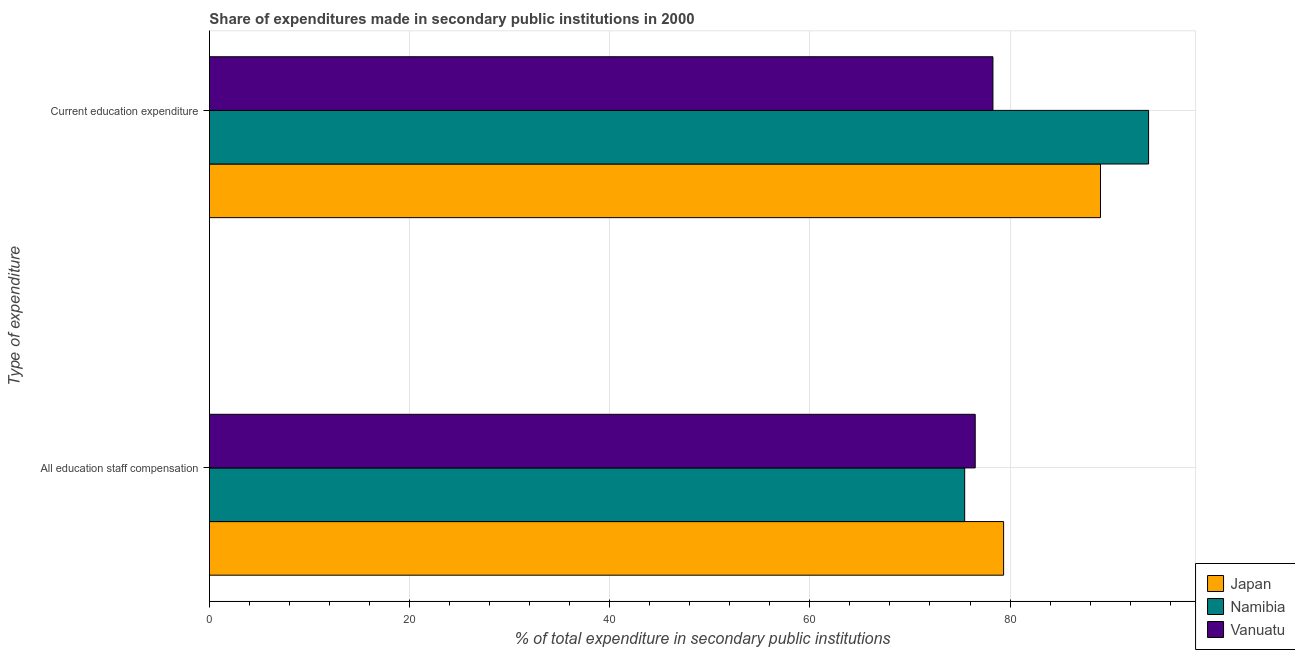How many different coloured bars are there?
Your answer should be very brief. 3. How many groups of bars are there?
Your answer should be very brief. 2. Are the number of bars on each tick of the Y-axis equal?
Offer a very short reply. Yes. How many bars are there on the 1st tick from the top?
Your answer should be compact. 3. How many bars are there on the 2nd tick from the bottom?
Offer a very short reply. 3. What is the label of the 2nd group of bars from the top?
Ensure brevity in your answer.  All education staff compensation. What is the expenditure in staff compensation in Japan?
Keep it short and to the point. 79.36. Across all countries, what is the maximum expenditure in staff compensation?
Your response must be concise. 79.36. Across all countries, what is the minimum expenditure in education?
Give a very brief answer. 78.29. In which country was the expenditure in staff compensation maximum?
Offer a terse response. Japan. In which country was the expenditure in staff compensation minimum?
Keep it short and to the point. Namibia. What is the total expenditure in education in the graph?
Your response must be concise. 261.17. What is the difference between the expenditure in education in Japan and that in Namibia?
Your answer should be compact. -4.8. What is the difference between the expenditure in staff compensation in Namibia and the expenditure in education in Japan?
Give a very brief answer. -13.57. What is the average expenditure in staff compensation per country?
Make the answer very short. 77.11. What is the difference between the expenditure in staff compensation and expenditure in education in Namibia?
Offer a terse response. -18.37. What is the ratio of the expenditure in education in Vanuatu to that in Japan?
Make the answer very short. 0.88. Is the expenditure in education in Japan less than that in Namibia?
Make the answer very short. Yes. In how many countries, is the expenditure in education greater than the average expenditure in education taken over all countries?
Ensure brevity in your answer.  2. What does the 1st bar from the top in Current education expenditure represents?
Make the answer very short. Vanuatu. How many bars are there?
Your response must be concise. 6. Are all the bars in the graph horizontal?
Make the answer very short. Yes. How many countries are there in the graph?
Your answer should be very brief. 3. Are the values on the major ticks of X-axis written in scientific E-notation?
Provide a short and direct response. No. Does the graph contain grids?
Your response must be concise. Yes. Where does the legend appear in the graph?
Your response must be concise. Bottom right. How are the legend labels stacked?
Your response must be concise. Vertical. What is the title of the graph?
Ensure brevity in your answer.  Share of expenditures made in secondary public institutions in 2000. What is the label or title of the X-axis?
Keep it short and to the point. % of total expenditure in secondary public institutions. What is the label or title of the Y-axis?
Keep it short and to the point. Type of expenditure. What is the % of total expenditure in secondary public institutions of Japan in All education staff compensation?
Offer a very short reply. 79.36. What is the % of total expenditure in secondary public institutions in Namibia in All education staff compensation?
Keep it short and to the point. 75.47. What is the % of total expenditure in secondary public institutions in Vanuatu in All education staff compensation?
Provide a succinct answer. 76.52. What is the % of total expenditure in secondary public institutions of Japan in Current education expenditure?
Provide a succinct answer. 89.04. What is the % of total expenditure in secondary public institutions in Namibia in Current education expenditure?
Keep it short and to the point. 93.84. What is the % of total expenditure in secondary public institutions of Vanuatu in Current education expenditure?
Provide a succinct answer. 78.29. Across all Type of expenditure, what is the maximum % of total expenditure in secondary public institutions of Japan?
Provide a succinct answer. 89.04. Across all Type of expenditure, what is the maximum % of total expenditure in secondary public institutions of Namibia?
Make the answer very short. 93.84. Across all Type of expenditure, what is the maximum % of total expenditure in secondary public institutions in Vanuatu?
Your answer should be compact. 78.29. Across all Type of expenditure, what is the minimum % of total expenditure in secondary public institutions of Japan?
Keep it short and to the point. 79.36. Across all Type of expenditure, what is the minimum % of total expenditure in secondary public institutions of Namibia?
Your response must be concise. 75.47. Across all Type of expenditure, what is the minimum % of total expenditure in secondary public institutions of Vanuatu?
Provide a short and direct response. 76.52. What is the total % of total expenditure in secondary public institutions in Japan in the graph?
Keep it short and to the point. 168.39. What is the total % of total expenditure in secondary public institutions in Namibia in the graph?
Provide a short and direct response. 169.31. What is the total % of total expenditure in secondary public institutions of Vanuatu in the graph?
Ensure brevity in your answer.  154.81. What is the difference between the % of total expenditure in secondary public institutions in Japan in All education staff compensation and that in Current education expenditure?
Give a very brief answer. -9.68. What is the difference between the % of total expenditure in secondary public institutions in Namibia in All education staff compensation and that in Current education expenditure?
Give a very brief answer. -18.37. What is the difference between the % of total expenditure in secondary public institutions in Vanuatu in All education staff compensation and that in Current education expenditure?
Offer a terse response. -1.77. What is the difference between the % of total expenditure in secondary public institutions in Japan in All education staff compensation and the % of total expenditure in secondary public institutions in Namibia in Current education expenditure?
Provide a succinct answer. -14.49. What is the difference between the % of total expenditure in secondary public institutions of Japan in All education staff compensation and the % of total expenditure in secondary public institutions of Vanuatu in Current education expenditure?
Offer a terse response. 1.06. What is the difference between the % of total expenditure in secondary public institutions in Namibia in All education staff compensation and the % of total expenditure in secondary public institutions in Vanuatu in Current education expenditure?
Make the answer very short. -2.82. What is the average % of total expenditure in secondary public institutions of Japan per Type of expenditure?
Provide a succinct answer. 84.2. What is the average % of total expenditure in secondary public institutions of Namibia per Type of expenditure?
Ensure brevity in your answer.  84.65. What is the average % of total expenditure in secondary public institutions of Vanuatu per Type of expenditure?
Keep it short and to the point. 77.4. What is the difference between the % of total expenditure in secondary public institutions of Japan and % of total expenditure in secondary public institutions of Namibia in All education staff compensation?
Keep it short and to the point. 3.89. What is the difference between the % of total expenditure in secondary public institutions in Japan and % of total expenditure in secondary public institutions in Vanuatu in All education staff compensation?
Keep it short and to the point. 2.84. What is the difference between the % of total expenditure in secondary public institutions in Namibia and % of total expenditure in secondary public institutions in Vanuatu in All education staff compensation?
Keep it short and to the point. -1.05. What is the difference between the % of total expenditure in secondary public institutions of Japan and % of total expenditure in secondary public institutions of Namibia in Current education expenditure?
Provide a short and direct response. -4.8. What is the difference between the % of total expenditure in secondary public institutions of Japan and % of total expenditure in secondary public institutions of Vanuatu in Current education expenditure?
Make the answer very short. 10.75. What is the difference between the % of total expenditure in secondary public institutions of Namibia and % of total expenditure in secondary public institutions of Vanuatu in Current education expenditure?
Offer a terse response. 15.55. What is the ratio of the % of total expenditure in secondary public institutions in Japan in All education staff compensation to that in Current education expenditure?
Your answer should be very brief. 0.89. What is the ratio of the % of total expenditure in secondary public institutions of Namibia in All education staff compensation to that in Current education expenditure?
Your answer should be compact. 0.8. What is the ratio of the % of total expenditure in secondary public institutions in Vanuatu in All education staff compensation to that in Current education expenditure?
Provide a short and direct response. 0.98. What is the difference between the highest and the second highest % of total expenditure in secondary public institutions in Japan?
Ensure brevity in your answer.  9.68. What is the difference between the highest and the second highest % of total expenditure in secondary public institutions of Namibia?
Make the answer very short. 18.37. What is the difference between the highest and the second highest % of total expenditure in secondary public institutions in Vanuatu?
Keep it short and to the point. 1.77. What is the difference between the highest and the lowest % of total expenditure in secondary public institutions of Japan?
Provide a short and direct response. 9.68. What is the difference between the highest and the lowest % of total expenditure in secondary public institutions in Namibia?
Ensure brevity in your answer.  18.37. What is the difference between the highest and the lowest % of total expenditure in secondary public institutions of Vanuatu?
Your response must be concise. 1.77. 